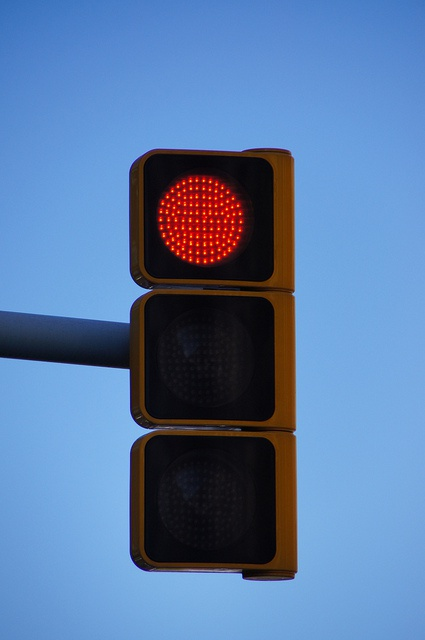Describe the objects in this image and their specific colors. I can see a traffic light in blue, black, maroon, and red tones in this image. 